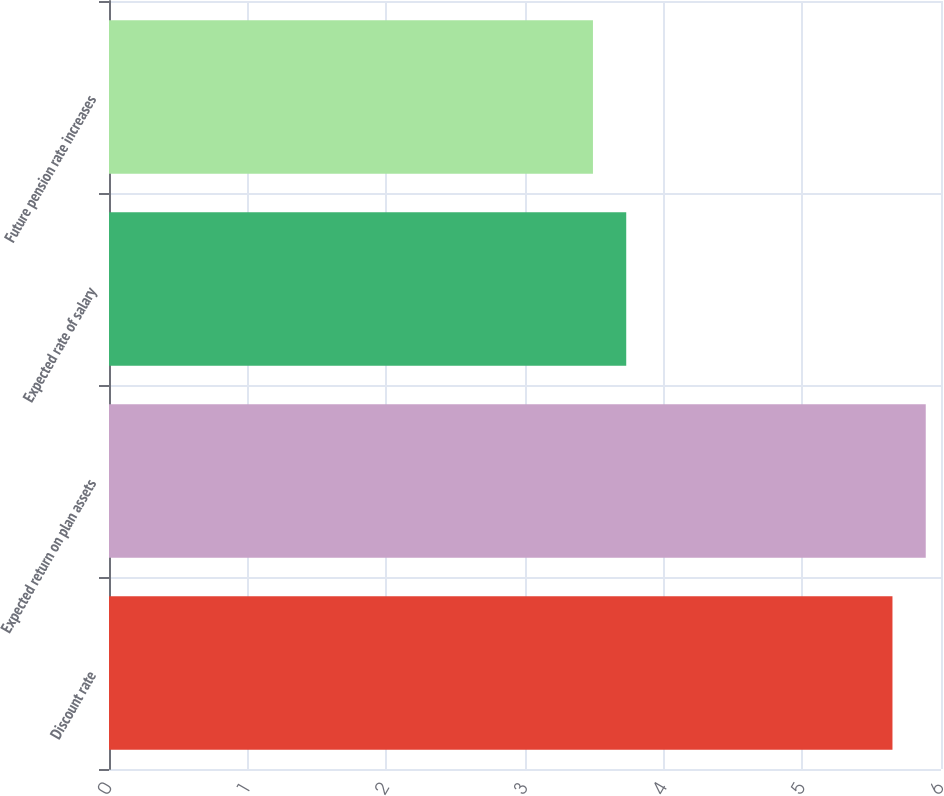Convert chart to OTSL. <chart><loc_0><loc_0><loc_500><loc_500><bar_chart><fcel>Discount rate<fcel>Expected return on plan assets<fcel>Expected rate of salary<fcel>Future pension rate increases<nl><fcel>5.65<fcel>5.89<fcel>3.73<fcel>3.49<nl></chart> 